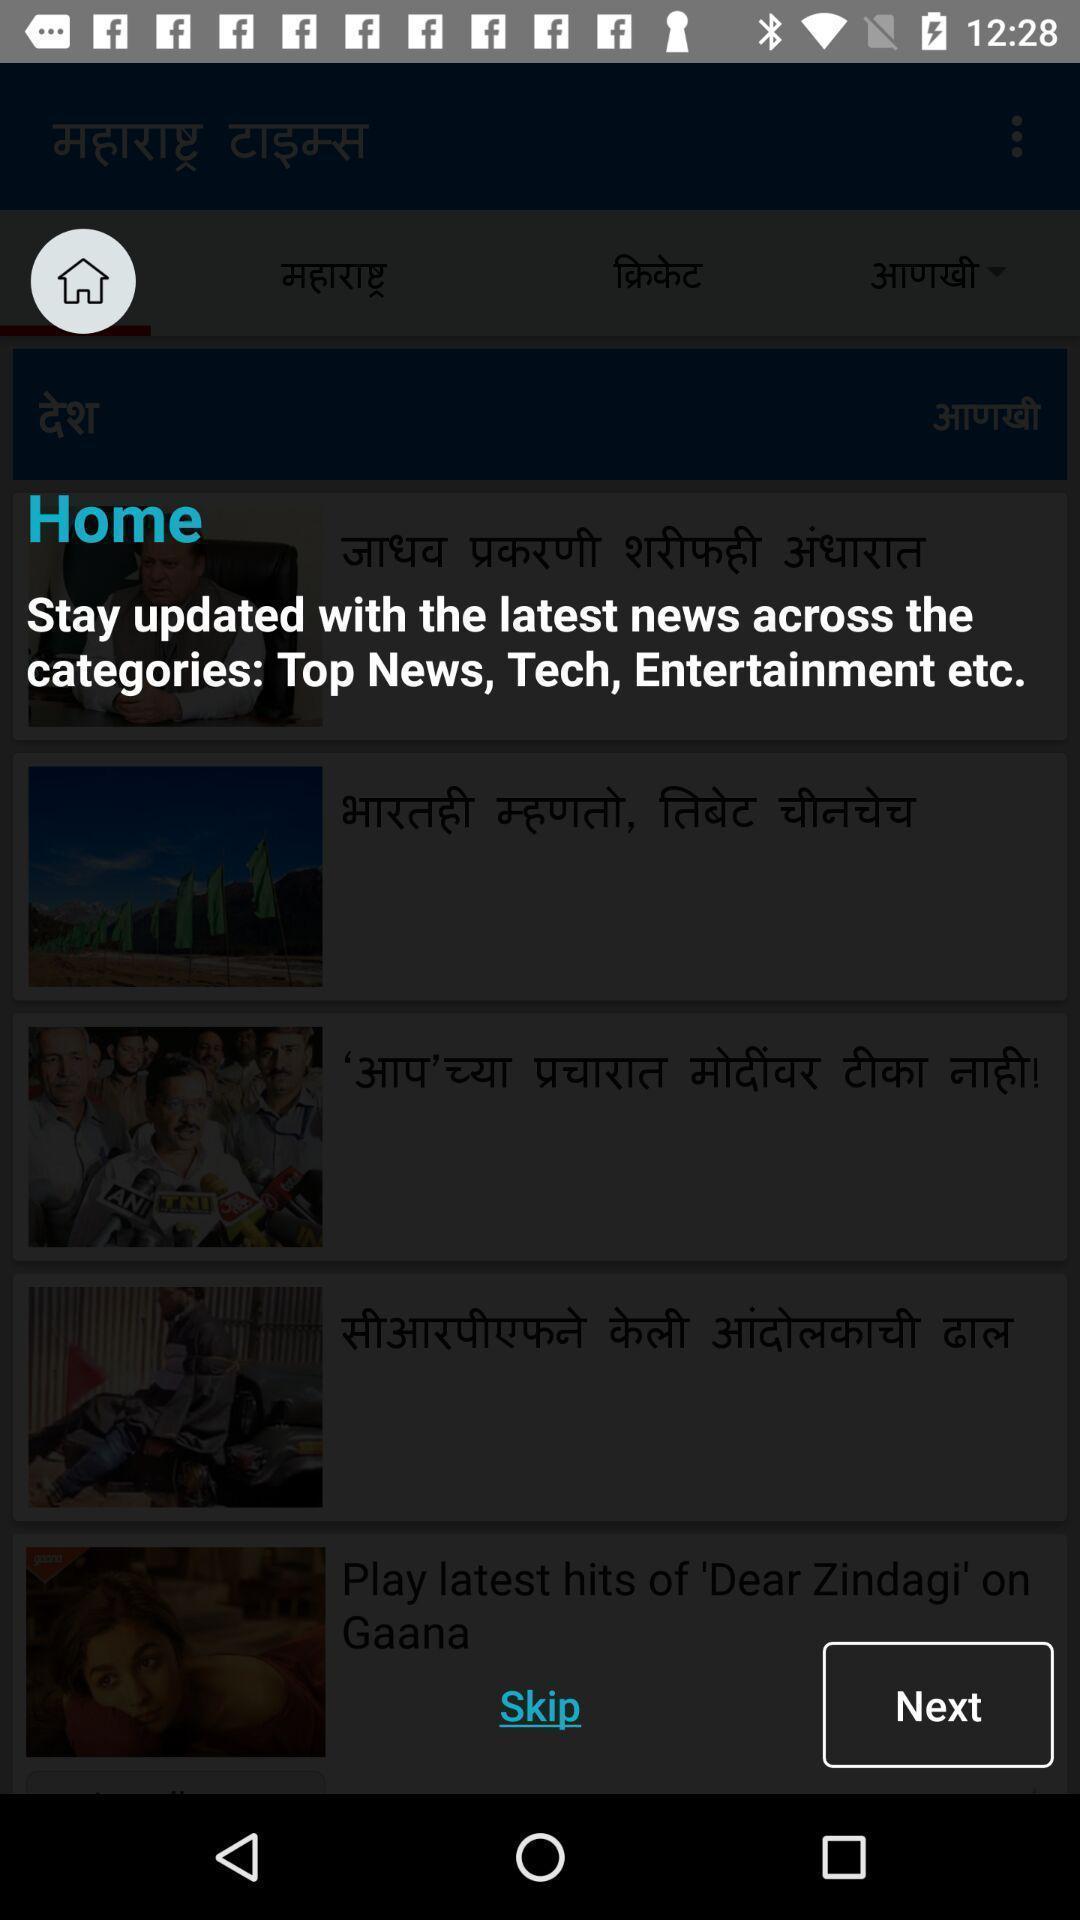Tell me what you see in this picture. Popup showing information about home. 